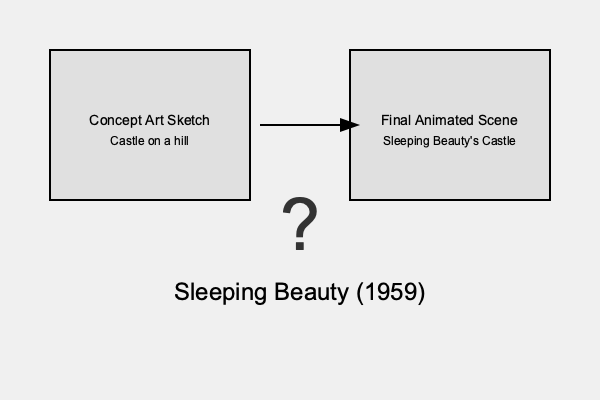Which Disney animated feature film's iconic castle was inspired by the real-life Neuschwanstein Castle in Bavaria, Germany, as evidenced by early concept art sketches? To answer this question, let's follow these steps:

1. Analyze the image: The graphic shows a concept art sketch on the left and a final animated scene on the right, connected by an arrow. This suggests a progression from initial design to final product.

2. Identify the subject: The sketch and final scene both depict a castle on a hill, which is a common element in Disney films.

3. Note the movie title: At the bottom of the image, we see "Sleeping Beauty (1959)" mentioned.

4. Consider the question: We're asked about a Disney castle inspired by Neuschwanstein Castle in Bavaria.

5. Historical context: Neuschwanstein Castle is known for its fairy-tale appearance and has often been associated with Disney's castle imagery.

6. Connect the dots: Sleeping Beauty's castle, as seen in the 1959 film, is one of the most iconic Disney castles and bears a strong resemblance to Neuschwanstein.

7. Confirmation: The concept art sketch showing a castle on a hill, leading to the final animated scene of Sleeping Beauty's castle, supports this connection.

Therefore, the Disney animated feature film whose iconic castle was inspired by Neuschwanstein Castle, as evidenced by early concept art sketches, is Sleeping Beauty.
Answer: Sleeping Beauty 